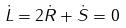<formula> <loc_0><loc_0><loc_500><loc_500>\dot { L } = 2 \dot { R } + \dot { S } = 0</formula> 